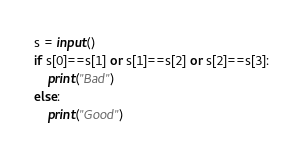<code> <loc_0><loc_0><loc_500><loc_500><_Python_>s = input()
if s[0]==s[1] or s[1]==s[2] or s[2]==s[3]:
    print("Bad")
else:
    print("Good")</code> 